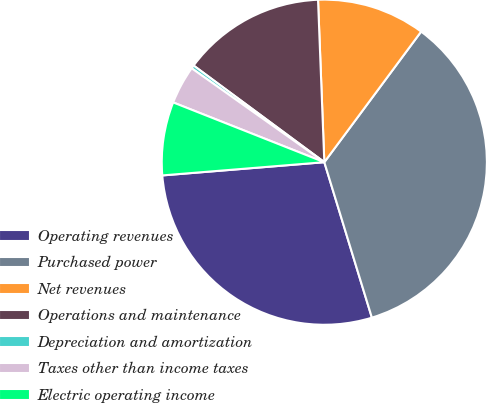<chart> <loc_0><loc_0><loc_500><loc_500><pie_chart><fcel>Operating revenues<fcel>Purchased power<fcel>Net revenues<fcel>Operations and maintenance<fcel>Depreciation and amortization<fcel>Taxes other than income taxes<fcel>Electric operating income<nl><fcel>28.43%<fcel>35.12%<fcel>10.77%<fcel>14.25%<fcel>0.33%<fcel>3.81%<fcel>7.29%<nl></chart> 